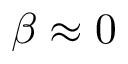<formula> <loc_0><loc_0><loc_500><loc_500>\beta \approx 0</formula> 